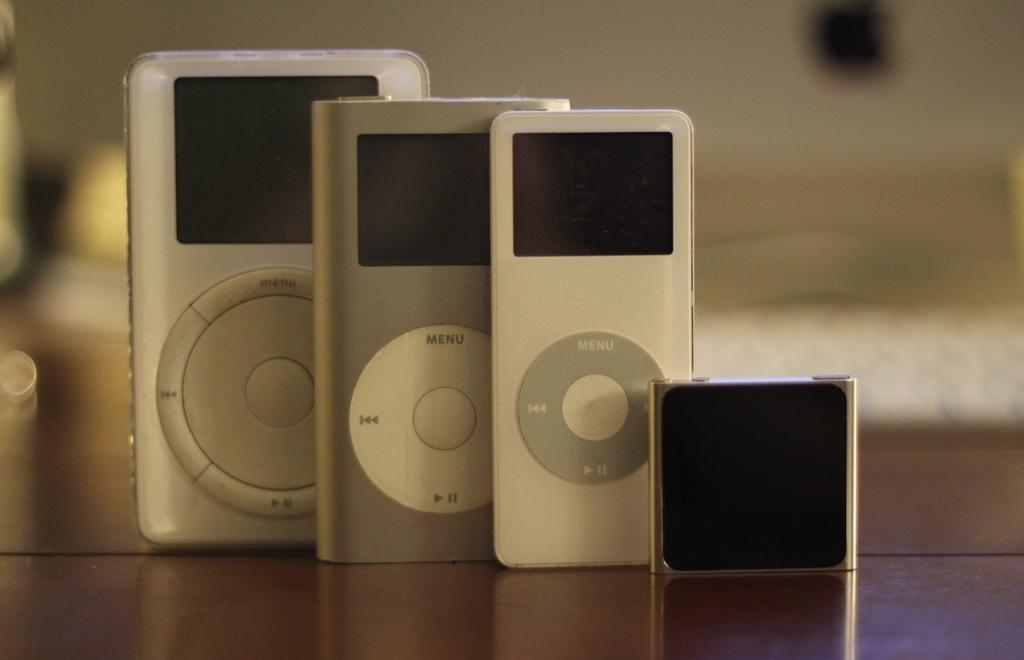<image>
Provide a brief description of the given image. A collection of various apple products with the menu, fast forward and pause buttons visible. 